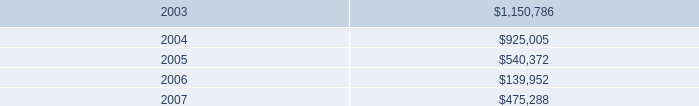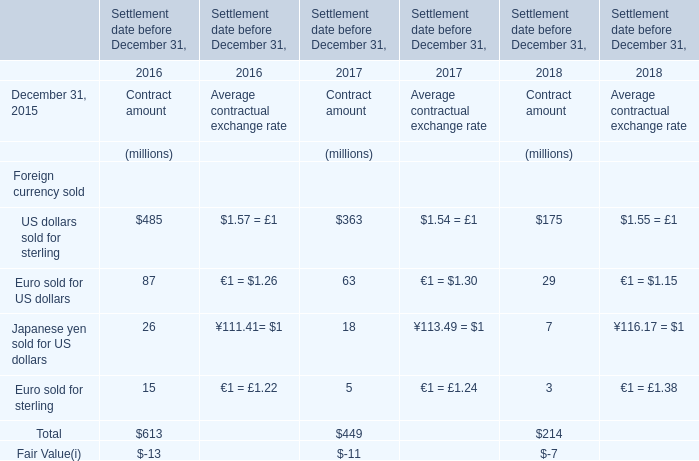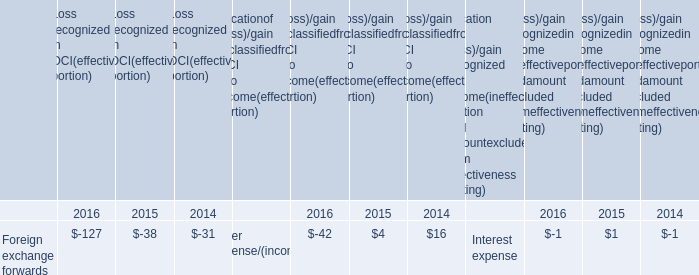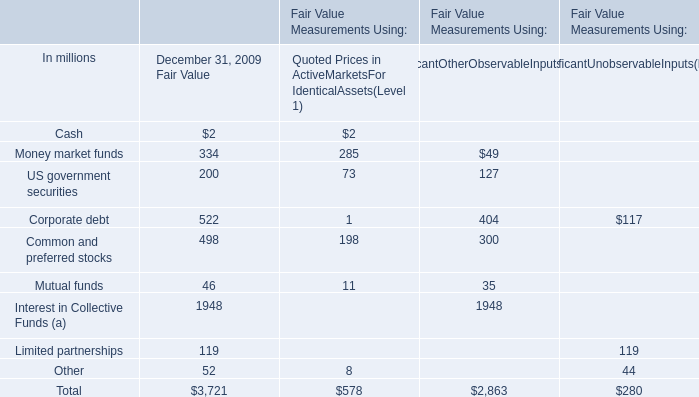What's the 50 % of the Fair Value for Mutual funds at December 31, 2009? (in million) 
Computations: (0.5 * 46)
Answer: 23.0. 